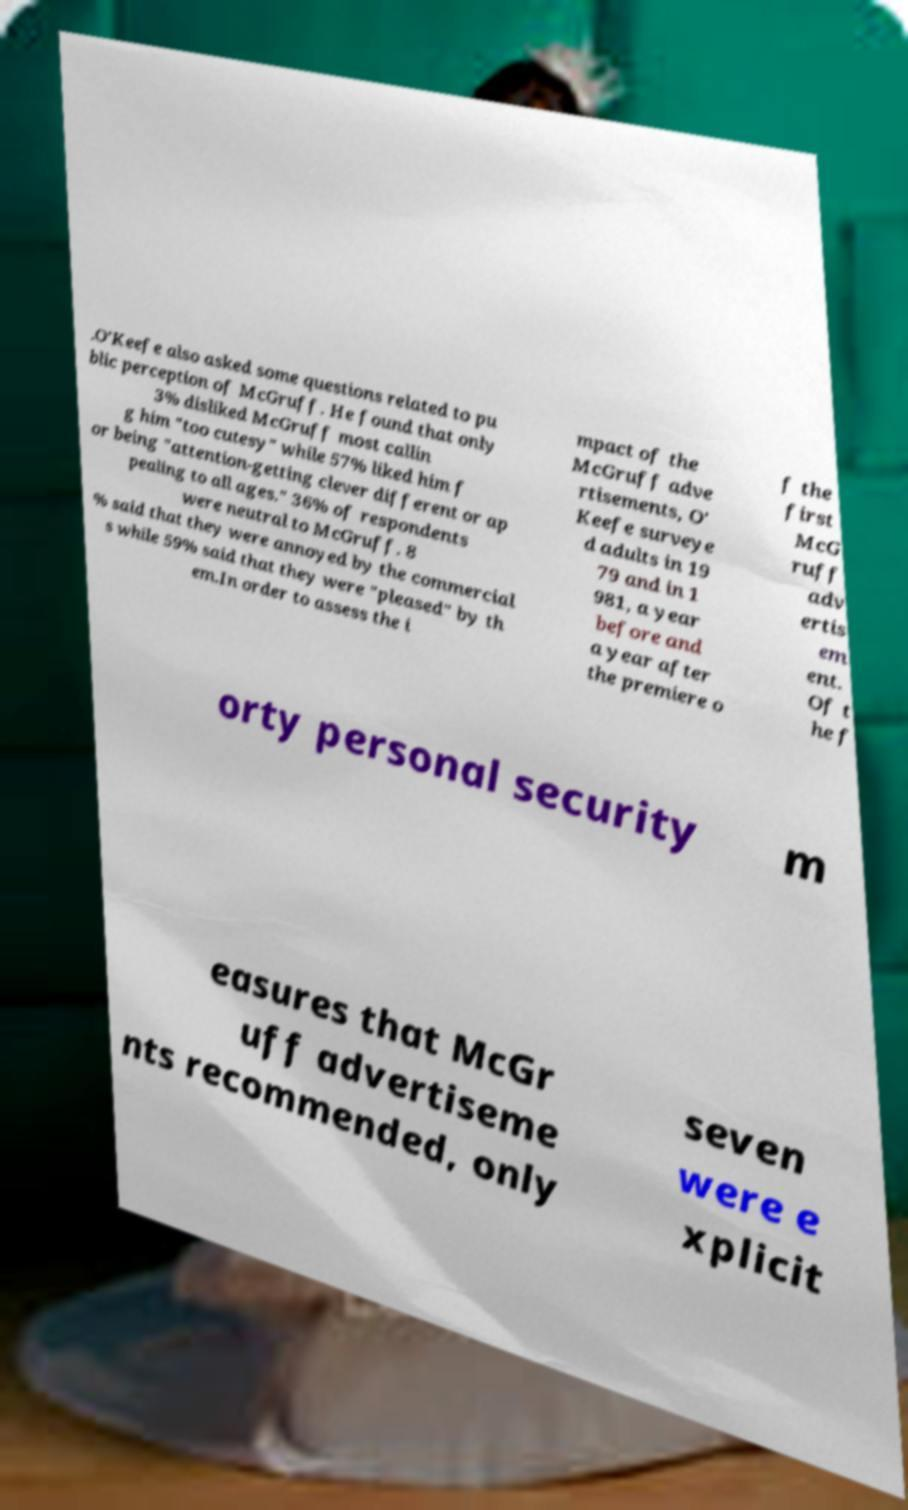Please identify and transcribe the text found in this image. .O'Keefe also asked some questions related to pu blic perception of McGruff. He found that only 3% disliked McGruff most callin g him "too cutesy" while 57% liked him f or being "attention-getting clever different or ap pealing to all ages." 36% of respondents were neutral to McGruff. 8 % said that they were annoyed by the commercial s while 59% said that they were "pleased" by th em.In order to assess the i mpact of the McGruff adve rtisements, O' Keefe surveye d adults in 19 79 and in 1 981, a year before and a year after the premiere o f the first McG ruff adv ertis em ent. Of t he f orty personal security m easures that McGr uff advertiseme nts recommended, only seven were e xplicit 